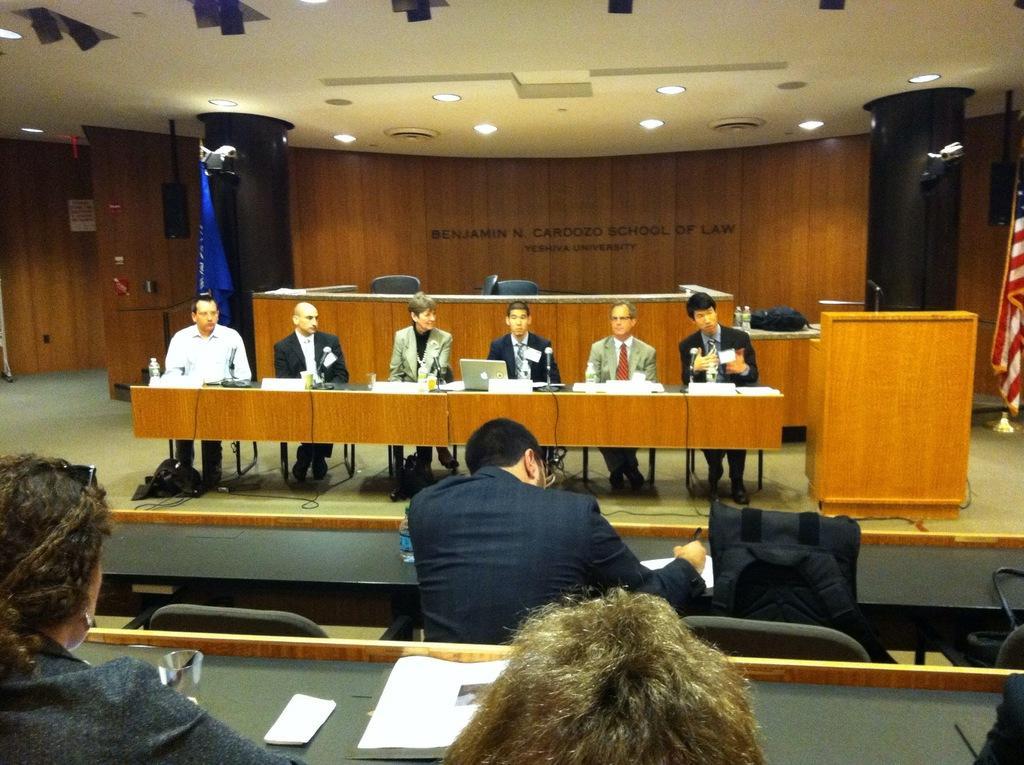How would you summarize this image in a sentence or two? Here we can see few persons are sitting on the chairs. There are tables. On the table there are papers, glasses, bottles, and a laptop. There is a podium. Here we can see chairs, flags, lights, floor, and wall. There is ceiling. 